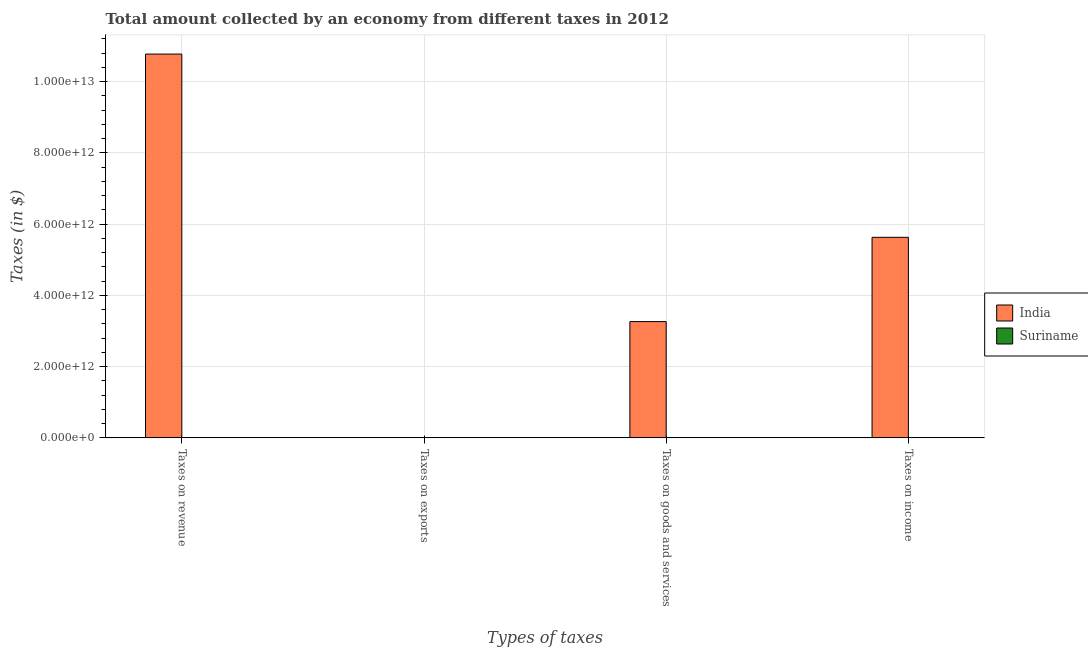How many groups of bars are there?
Provide a succinct answer. 4. Are the number of bars on each tick of the X-axis equal?
Keep it short and to the point. Yes. What is the label of the 1st group of bars from the left?
Offer a very short reply. Taxes on revenue. What is the amount collected as tax on revenue in India?
Your answer should be compact. 1.08e+13. Across all countries, what is the maximum amount collected as tax on income?
Offer a very short reply. 5.63e+12. Across all countries, what is the minimum amount collected as tax on revenue?
Provide a succinct answer. 3.21e+09. In which country was the amount collected as tax on exports maximum?
Provide a short and direct response. India. In which country was the amount collected as tax on goods minimum?
Make the answer very short. Suriname. What is the total amount collected as tax on income in the graph?
Provide a short and direct response. 5.63e+12. What is the difference between the amount collected as tax on income in India and that in Suriname?
Offer a terse response. 5.63e+12. What is the difference between the amount collected as tax on revenue in Suriname and the amount collected as tax on exports in India?
Offer a terse response. 2.51e+09. What is the average amount collected as tax on revenue per country?
Your response must be concise. 5.39e+12. What is the difference between the amount collected as tax on goods and amount collected as tax on income in Suriname?
Offer a very short reply. -1.13e+08. In how many countries, is the amount collected as tax on goods greater than 5200000000000 $?
Provide a succinct answer. 0. What is the ratio of the amount collected as tax on revenue in India to that in Suriname?
Offer a terse response. 3354.51. What is the difference between the highest and the second highest amount collected as tax on goods?
Offer a very short reply. 3.26e+12. What is the difference between the highest and the lowest amount collected as tax on exports?
Your answer should be very brief. 6.91e+08. In how many countries, is the amount collected as tax on income greater than the average amount collected as tax on income taken over all countries?
Your response must be concise. 1. Is the sum of the amount collected as tax on exports in Suriname and India greater than the maximum amount collected as tax on goods across all countries?
Make the answer very short. No. What does the 2nd bar from the left in Taxes on goods and services represents?
Make the answer very short. Suriname. What does the 1st bar from the right in Taxes on goods and services represents?
Provide a short and direct response. Suriname. Is it the case that in every country, the sum of the amount collected as tax on revenue and amount collected as tax on exports is greater than the amount collected as tax on goods?
Your response must be concise. Yes. How many bars are there?
Provide a succinct answer. 8. Are all the bars in the graph horizontal?
Your answer should be very brief. No. What is the difference between two consecutive major ticks on the Y-axis?
Give a very brief answer. 2.00e+12. Does the graph contain any zero values?
Offer a terse response. No. How are the legend labels stacked?
Your answer should be very brief. Vertical. What is the title of the graph?
Your answer should be very brief. Total amount collected by an economy from different taxes in 2012. What is the label or title of the X-axis?
Keep it short and to the point. Types of taxes. What is the label or title of the Y-axis?
Your answer should be very brief. Taxes (in $). What is the Taxes (in $) of India in Taxes on revenue?
Offer a terse response. 1.08e+13. What is the Taxes (in $) of Suriname in Taxes on revenue?
Give a very brief answer. 3.21e+09. What is the Taxes (in $) in India in Taxes on exports?
Your answer should be very brief. 7.00e+08. What is the Taxes (in $) of Suriname in Taxes on exports?
Offer a very short reply. 9.10e+06. What is the Taxes (in $) of India in Taxes on goods and services?
Make the answer very short. 3.26e+12. What is the Taxes (in $) in Suriname in Taxes on goods and services?
Your response must be concise. 1.23e+09. What is the Taxes (in $) in India in Taxes on income?
Keep it short and to the point. 5.63e+12. What is the Taxes (in $) of Suriname in Taxes on income?
Offer a very short reply. 1.34e+09. Across all Types of taxes, what is the maximum Taxes (in $) of India?
Ensure brevity in your answer.  1.08e+13. Across all Types of taxes, what is the maximum Taxes (in $) of Suriname?
Your response must be concise. 3.21e+09. Across all Types of taxes, what is the minimum Taxes (in $) in India?
Offer a terse response. 7.00e+08. Across all Types of taxes, what is the minimum Taxes (in $) of Suriname?
Offer a very short reply. 9.10e+06. What is the total Taxes (in $) in India in the graph?
Your answer should be compact. 1.97e+13. What is the total Taxes (in $) in Suriname in the graph?
Give a very brief answer. 5.80e+09. What is the difference between the Taxes (in $) in India in Taxes on revenue and that in Taxes on exports?
Make the answer very short. 1.08e+13. What is the difference between the Taxes (in $) in Suriname in Taxes on revenue and that in Taxes on exports?
Ensure brevity in your answer.  3.20e+09. What is the difference between the Taxes (in $) in India in Taxes on revenue and that in Taxes on goods and services?
Your response must be concise. 7.51e+12. What is the difference between the Taxes (in $) in Suriname in Taxes on revenue and that in Taxes on goods and services?
Provide a succinct answer. 1.98e+09. What is the difference between the Taxes (in $) in India in Taxes on revenue and that in Taxes on income?
Offer a terse response. 5.15e+12. What is the difference between the Taxes (in $) in Suriname in Taxes on revenue and that in Taxes on income?
Your answer should be compact. 1.87e+09. What is the difference between the Taxes (in $) of India in Taxes on exports and that in Taxes on goods and services?
Your answer should be very brief. -3.26e+12. What is the difference between the Taxes (in $) of Suriname in Taxes on exports and that in Taxes on goods and services?
Provide a short and direct response. -1.22e+09. What is the difference between the Taxes (in $) of India in Taxes on exports and that in Taxes on income?
Keep it short and to the point. -5.63e+12. What is the difference between the Taxes (in $) of Suriname in Taxes on exports and that in Taxes on income?
Your answer should be very brief. -1.34e+09. What is the difference between the Taxes (in $) of India in Taxes on goods and services and that in Taxes on income?
Your response must be concise. -2.37e+12. What is the difference between the Taxes (in $) in Suriname in Taxes on goods and services and that in Taxes on income?
Offer a very short reply. -1.13e+08. What is the difference between the Taxes (in $) of India in Taxes on revenue and the Taxes (in $) of Suriname in Taxes on exports?
Keep it short and to the point. 1.08e+13. What is the difference between the Taxes (in $) of India in Taxes on revenue and the Taxes (in $) of Suriname in Taxes on goods and services?
Provide a succinct answer. 1.08e+13. What is the difference between the Taxes (in $) in India in Taxes on revenue and the Taxes (in $) in Suriname in Taxes on income?
Give a very brief answer. 1.08e+13. What is the difference between the Taxes (in $) in India in Taxes on exports and the Taxes (in $) in Suriname in Taxes on goods and services?
Make the answer very short. -5.31e+08. What is the difference between the Taxes (in $) of India in Taxes on exports and the Taxes (in $) of Suriname in Taxes on income?
Your response must be concise. -6.45e+08. What is the difference between the Taxes (in $) in India in Taxes on goods and services and the Taxes (in $) in Suriname in Taxes on income?
Give a very brief answer. 3.26e+12. What is the average Taxes (in $) of India per Types of taxes?
Keep it short and to the point. 4.92e+12. What is the average Taxes (in $) of Suriname per Types of taxes?
Give a very brief answer. 1.45e+09. What is the difference between the Taxes (in $) in India and Taxes (in $) in Suriname in Taxes on revenue?
Offer a terse response. 1.08e+13. What is the difference between the Taxes (in $) in India and Taxes (in $) in Suriname in Taxes on exports?
Provide a short and direct response. 6.91e+08. What is the difference between the Taxes (in $) in India and Taxes (in $) in Suriname in Taxes on goods and services?
Provide a succinct answer. 3.26e+12. What is the difference between the Taxes (in $) of India and Taxes (in $) of Suriname in Taxes on income?
Ensure brevity in your answer.  5.63e+12. What is the ratio of the Taxes (in $) of India in Taxes on revenue to that in Taxes on exports?
Your answer should be compact. 1.54e+04. What is the ratio of the Taxes (in $) of Suriname in Taxes on revenue to that in Taxes on exports?
Give a very brief answer. 352.92. What is the ratio of the Taxes (in $) of India in Taxes on revenue to that in Taxes on goods and services?
Provide a succinct answer. 3.3. What is the ratio of the Taxes (in $) in Suriname in Taxes on revenue to that in Taxes on goods and services?
Keep it short and to the point. 2.61. What is the ratio of the Taxes (in $) in India in Taxes on revenue to that in Taxes on income?
Your answer should be very brief. 1.91. What is the ratio of the Taxes (in $) in Suriname in Taxes on revenue to that in Taxes on income?
Provide a short and direct response. 2.39. What is the ratio of the Taxes (in $) in India in Taxes on exports to that in Taxes on goods and services?
Ensure brevity in your answer.  0. What is the ratio of the Taxes (in $) of Suriname in Taxes on exports to that in Taxes on goods and services?
Your answer should be very brief. 0.01. What is the ratio of the Taxes (in $) in India in Taxes on exports to that in Taxes on income?
Offer a terse response. 0. What is the ratio of the Taxes (in $) in Suriname in Taxes on exports to that in Taxes on income?
Ensure brevity in your answer.  0.01. What is the ratio of the Taxes (in $) in India in Taxes on goods and services to that in Taxes on income?
Your answer should be compact. 0.58. What is the ratio of the Taxes (in $) of Suriname in Taxes on goods and services to that in Taxes on income?
Your answer should be very brief. 0.92. What is the difference between the highest and the second highest Taxes (in $) in India?
Keep it short and to the point. 5.15e+12. What is the difference between the highest and the second highest Taxes (in $) in Suriname?
Ensure brevity in your answer.  1.87e+09. What is the difference between the highest and the lowest Taxes (in $) of India?
Provide a short and direct response. 1.08e+13. What is the difference between the highest and the lowest Taxes (in $) in Suriname?
Your response must be concise. 3.20e+09. 